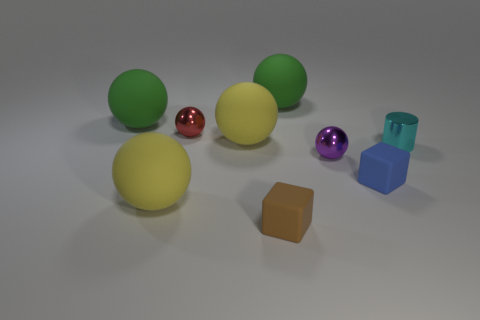Subtract all red shiny balls. How many balls are left? 5 Subtract all cyan blocks. How many yellow spheres are left? 2 Subtract all green balls. How many balls are left? 4 Subtract all cubes. How many objects are left? 7 Subtract all tiny cubes. Subtract all brown rubber things. How many objects are left? 6 Add 5 cyan cylinders. How many cyan cylinders are left? 6 Add 5 small red metal objects. How many small red metal objects exist? 6 Subtract 1 purple spheres. How many objects are left? 8 Subtract all brown spheres. Subtract all yellow cylinders. How many spheres are left? 6 